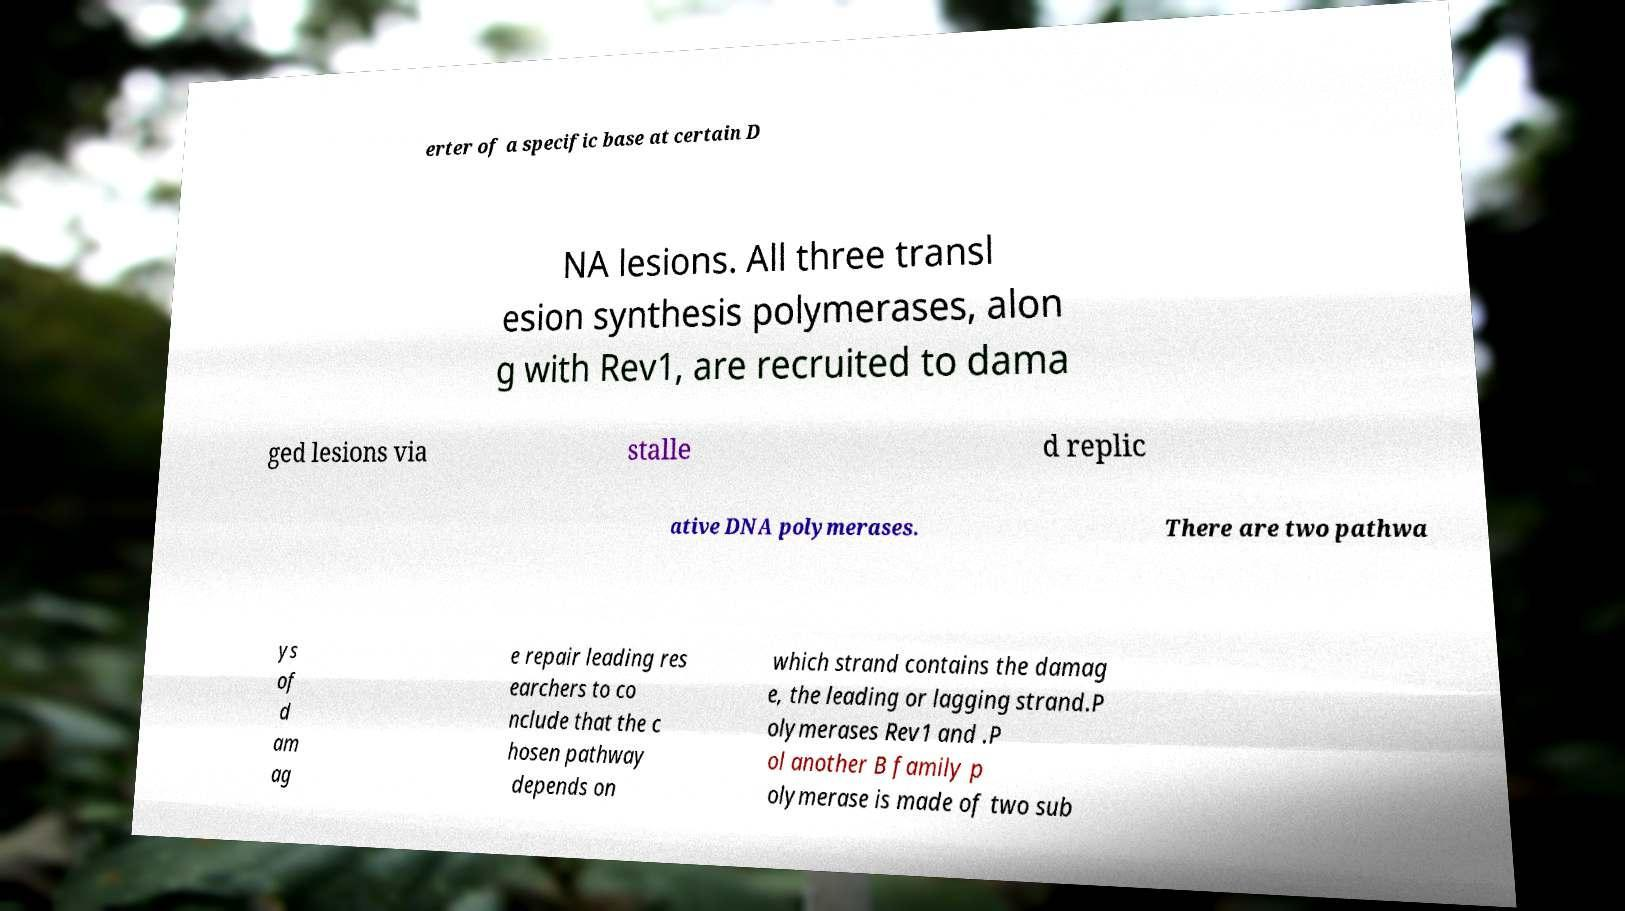Can you read and provide the text displayed in the image?This photo seems to have some interesting text. Can you extract and type it out for me? erter of a specific base at certain D NA lesions. All three transl esion synthesis polymerases, alon g with Rev1, are recruited to dama ged lesions via stalle d replic ative DNA polymerases. There are two pathwa ys of d am ag e repair leading res earchers to co nclude that the c hosen pathway depends on which strand contains the damag e, the leading or lagging strand.P olymerases Rev1 and .P ol another B family p olymerase is made of two sub 